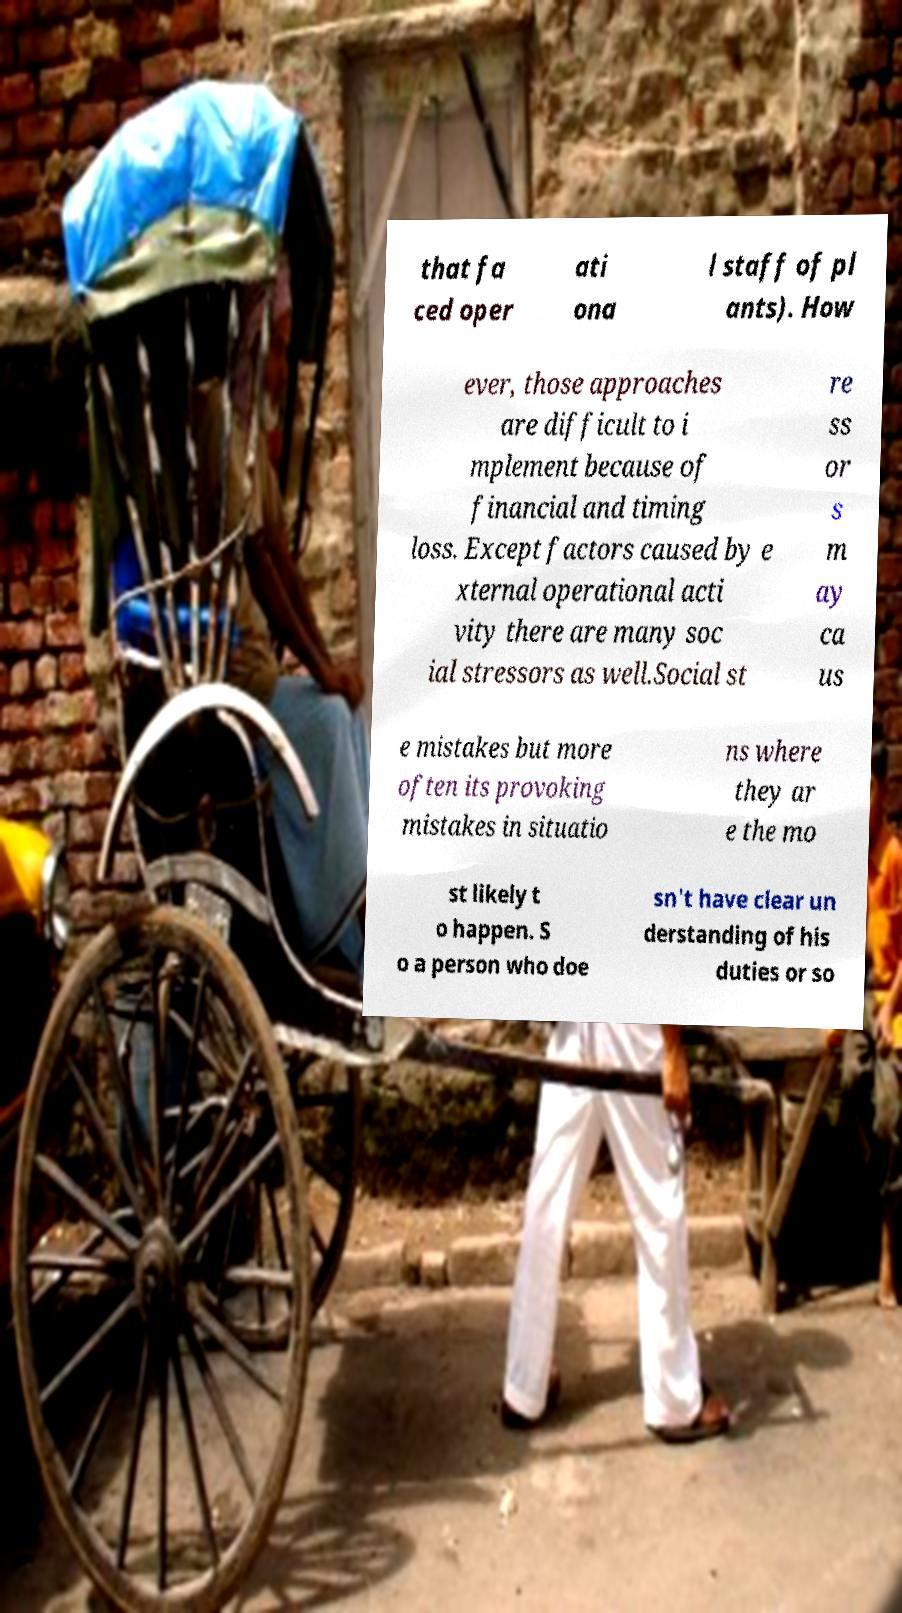For documentation purposes, I need the text within this image transcribed. Could you provide that? that fa ced oper ati ona l staff of pl ants). How ever, those approaches are difficult to i mplement because of financial and timing loss. Except factors caused by e xternal operational acti vity there are many soc ial stressors as well.Social st re ss or s m ay ca us e mistakes but more often its provoking mistakes in situatio ns where they ar e the mo st likely t o happen. S o a person who doe sn't have clear un derstanding of his duties or so 